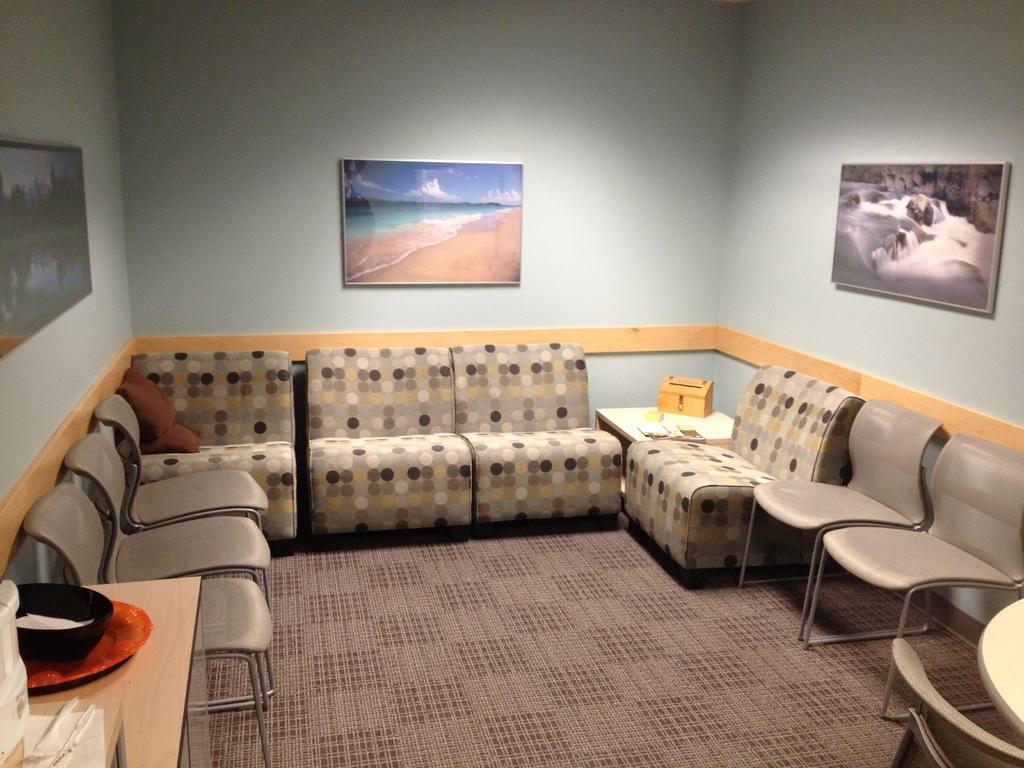Describe this image in one or two sentences. Here we can see the chairs on the floor, and here is the table and some objects on it, and at back here is the wall and photo frame on it. 